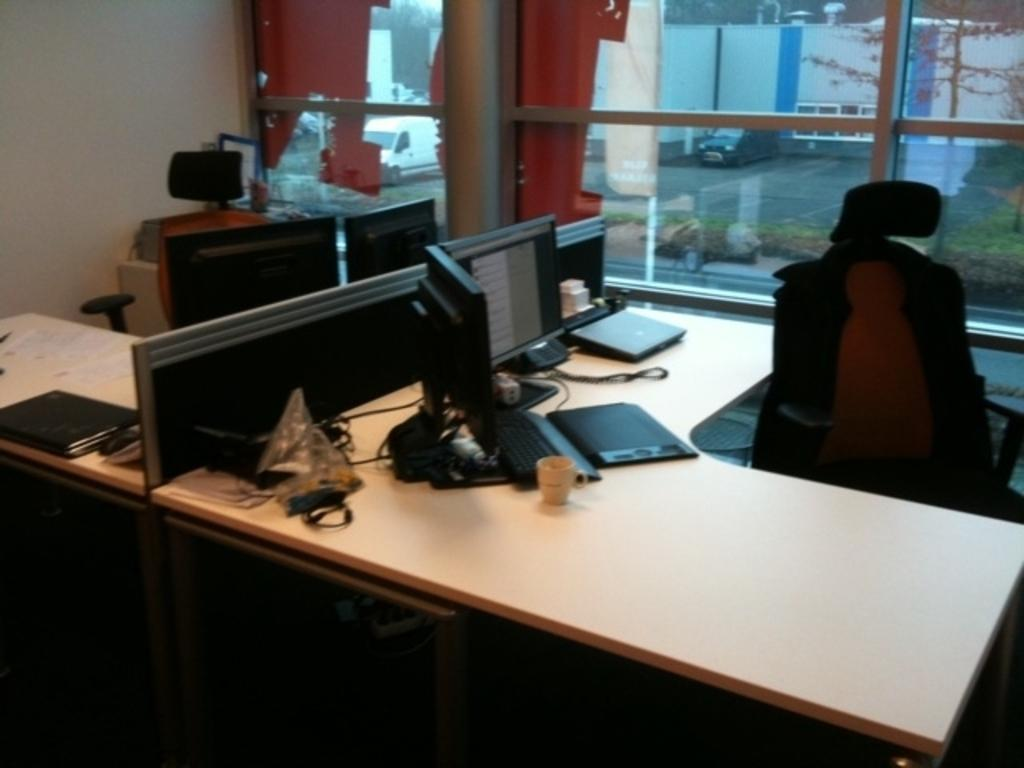What electronic devices are on the table in the image? There are monitors, laptops, and keyboards on the table in the image. What other object can be seen on the table? There is a telephone and a cup on the table. What type of seating is available near the table? There are chairs beside the table. What can be seen through the window in the room? Vehicles and plants are visible through the window. What type of soup is being served in the image? There is no soup present in the image. How many people are jumping in the image? There are no people jumping in the image. 